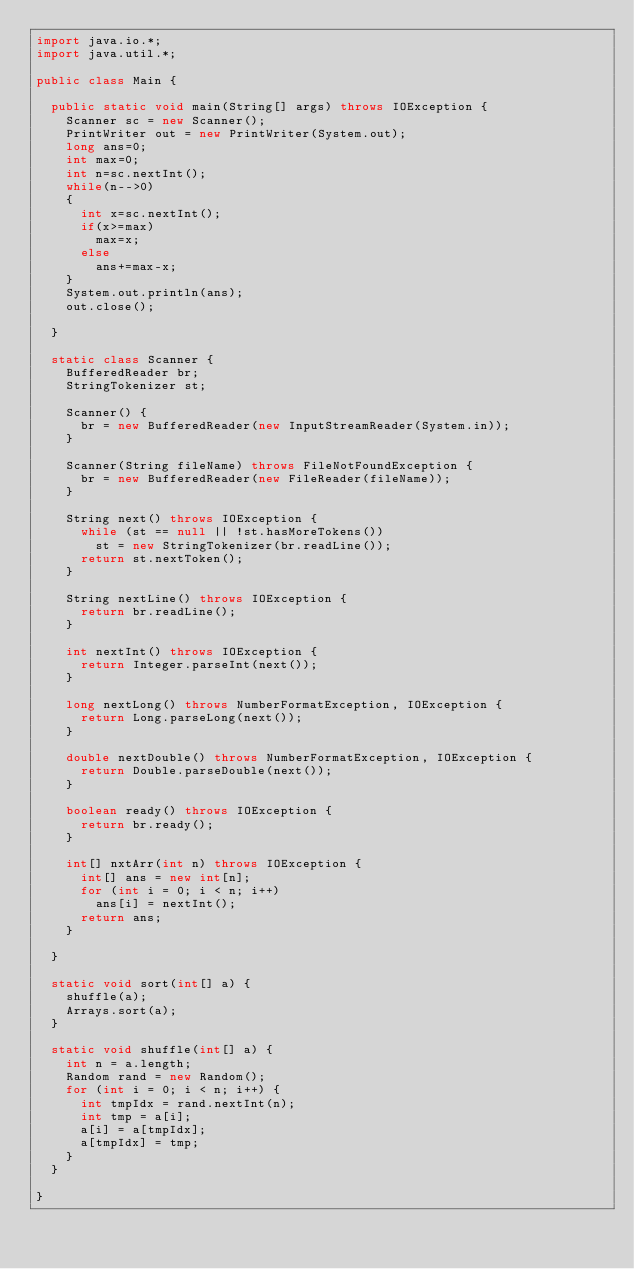<code> <loc_0><loc_0><loc_500><loc_500><_Java_>import java.io.*;
import java.util.*;

public class Main {

	public static void main(String[] args) throws IOException {
		Scanner sc = new Scanner();
		PrintWriter out = new PrintWriter(System.out);
		long ans=0;
		int max=0;
		int n=sc.nextInt();
		while(n-->0)
		{
			int x=sc.nextInt();
			if(x>=max)
				max=x;
			else
				ans+=max-x;
		}
		System.out.println(ans);
		out.close();

	}

	static class Scanner {
		BufferedReader br;
		StringTokenizer st;

		Scanner() {
			br = new BufferedReader(new InputStreamReader(System.in));
		}

		Scanner(String fileName) throws FileNotFoundException {
			br = new BufferedReader(new FileReader(fileName));
		}

		String next() throws IOException {
			while (st == null || !st.hasMoreTokens())
				st = new StringTokenizer(br.readLine());
			return st.nextToken();
		}

		String nextLine() throws IOException {
			return br.readLine();
		}

		int nextInt() throws IOException {
			return Integer.parseInt(next());
		}

		long nextLong() throws NumberFormatException, IOException {
			return Long.parseLong(next());
		}

		double nextDouble() throws NumberFormatException, IOException {
			return Double.parseDouble(next());
		}

		boolean ready() throws IOException {
			return br.ready();
		}

		int[] nxtArr(int n) throws IOException {
			int[] ans = new int[n];
			for (int i = 0; i < n; i++)
				ans[i] = nextInt();
			return ans;
		}

	}

	static void sort(int[] a) {
		shuffle(a);
		Arrays.sort(a);
	}

	static void shuffle(int[] a) {
		int n = a.length;
		Random rand = new Random();
		for (int i = 0; i < n; i++) {
			int tmpIdx = rand.nextInt(n);
			int tmp = a[i];
			a[i] = a[tmpIdx];
			a[tmpIdx] = tmp;
		}
	}

}</code> 